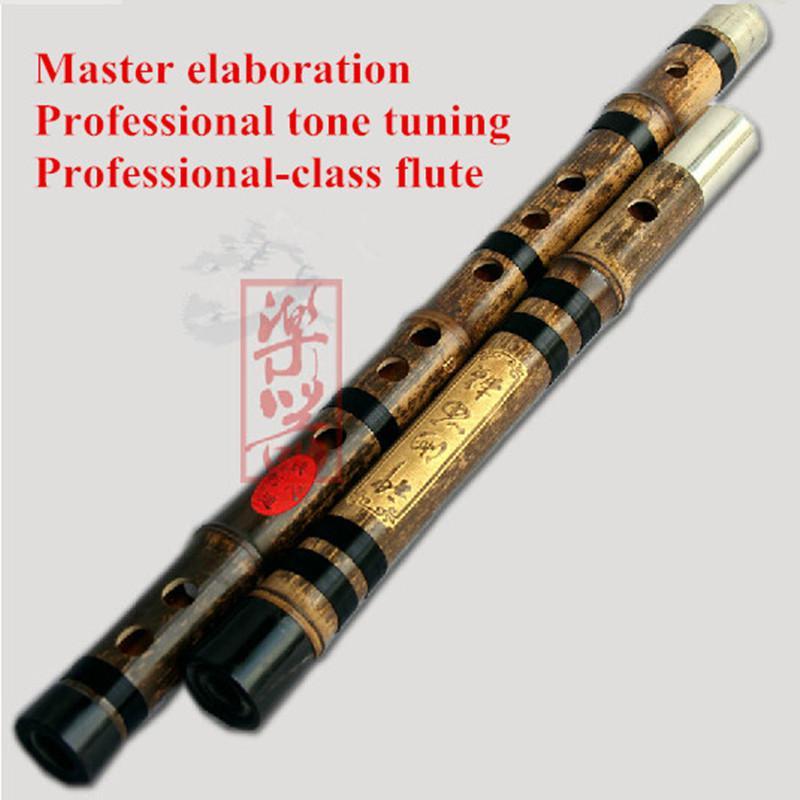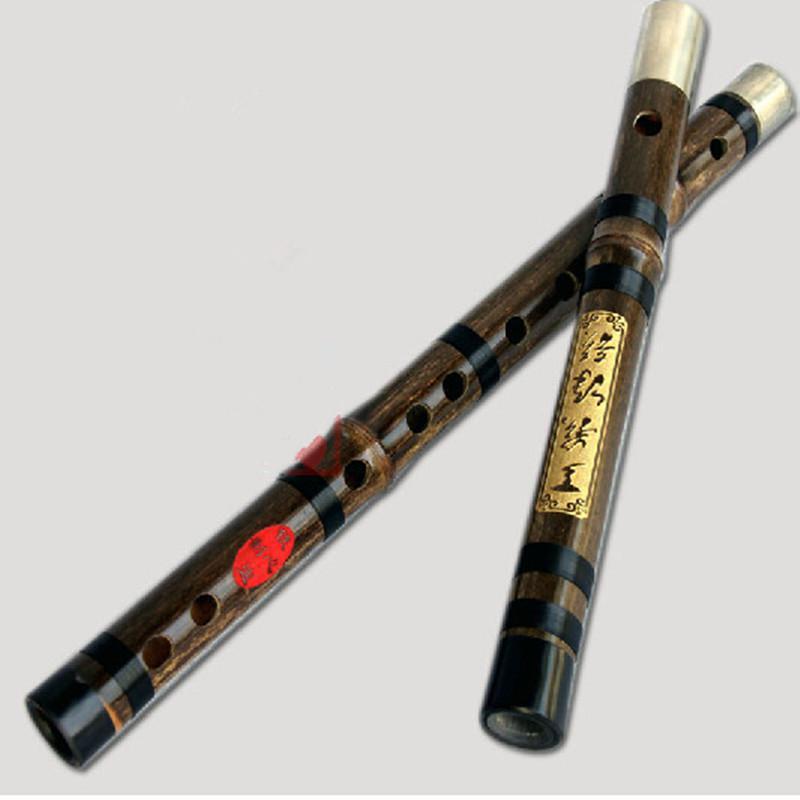The first image is the image on the left, the second image is the image on the right. Assess this claim about the two images: "The left image shows two flutes side-by-side, displayed diagonally with ends at the upper right.". Correct or not? Answer yes or no. Yes. The first image is the image on the left, the second image is the image on the right. For the images shown, is this caption "There are two disassembled flutes." true? Answer yes or no. Yes. 